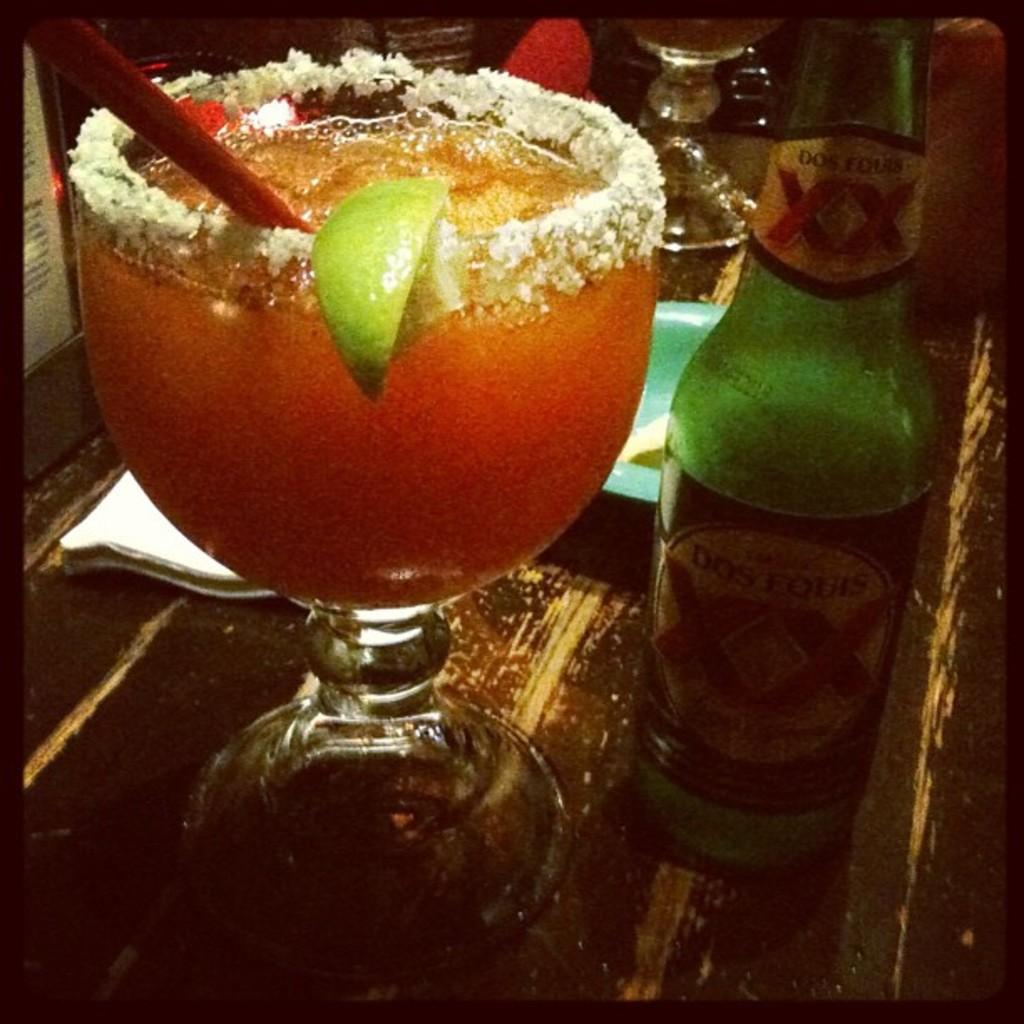<image>
Create a compact narrative representing the image presented. An ornate cocktail stands next to a bottle with XX written on it. 